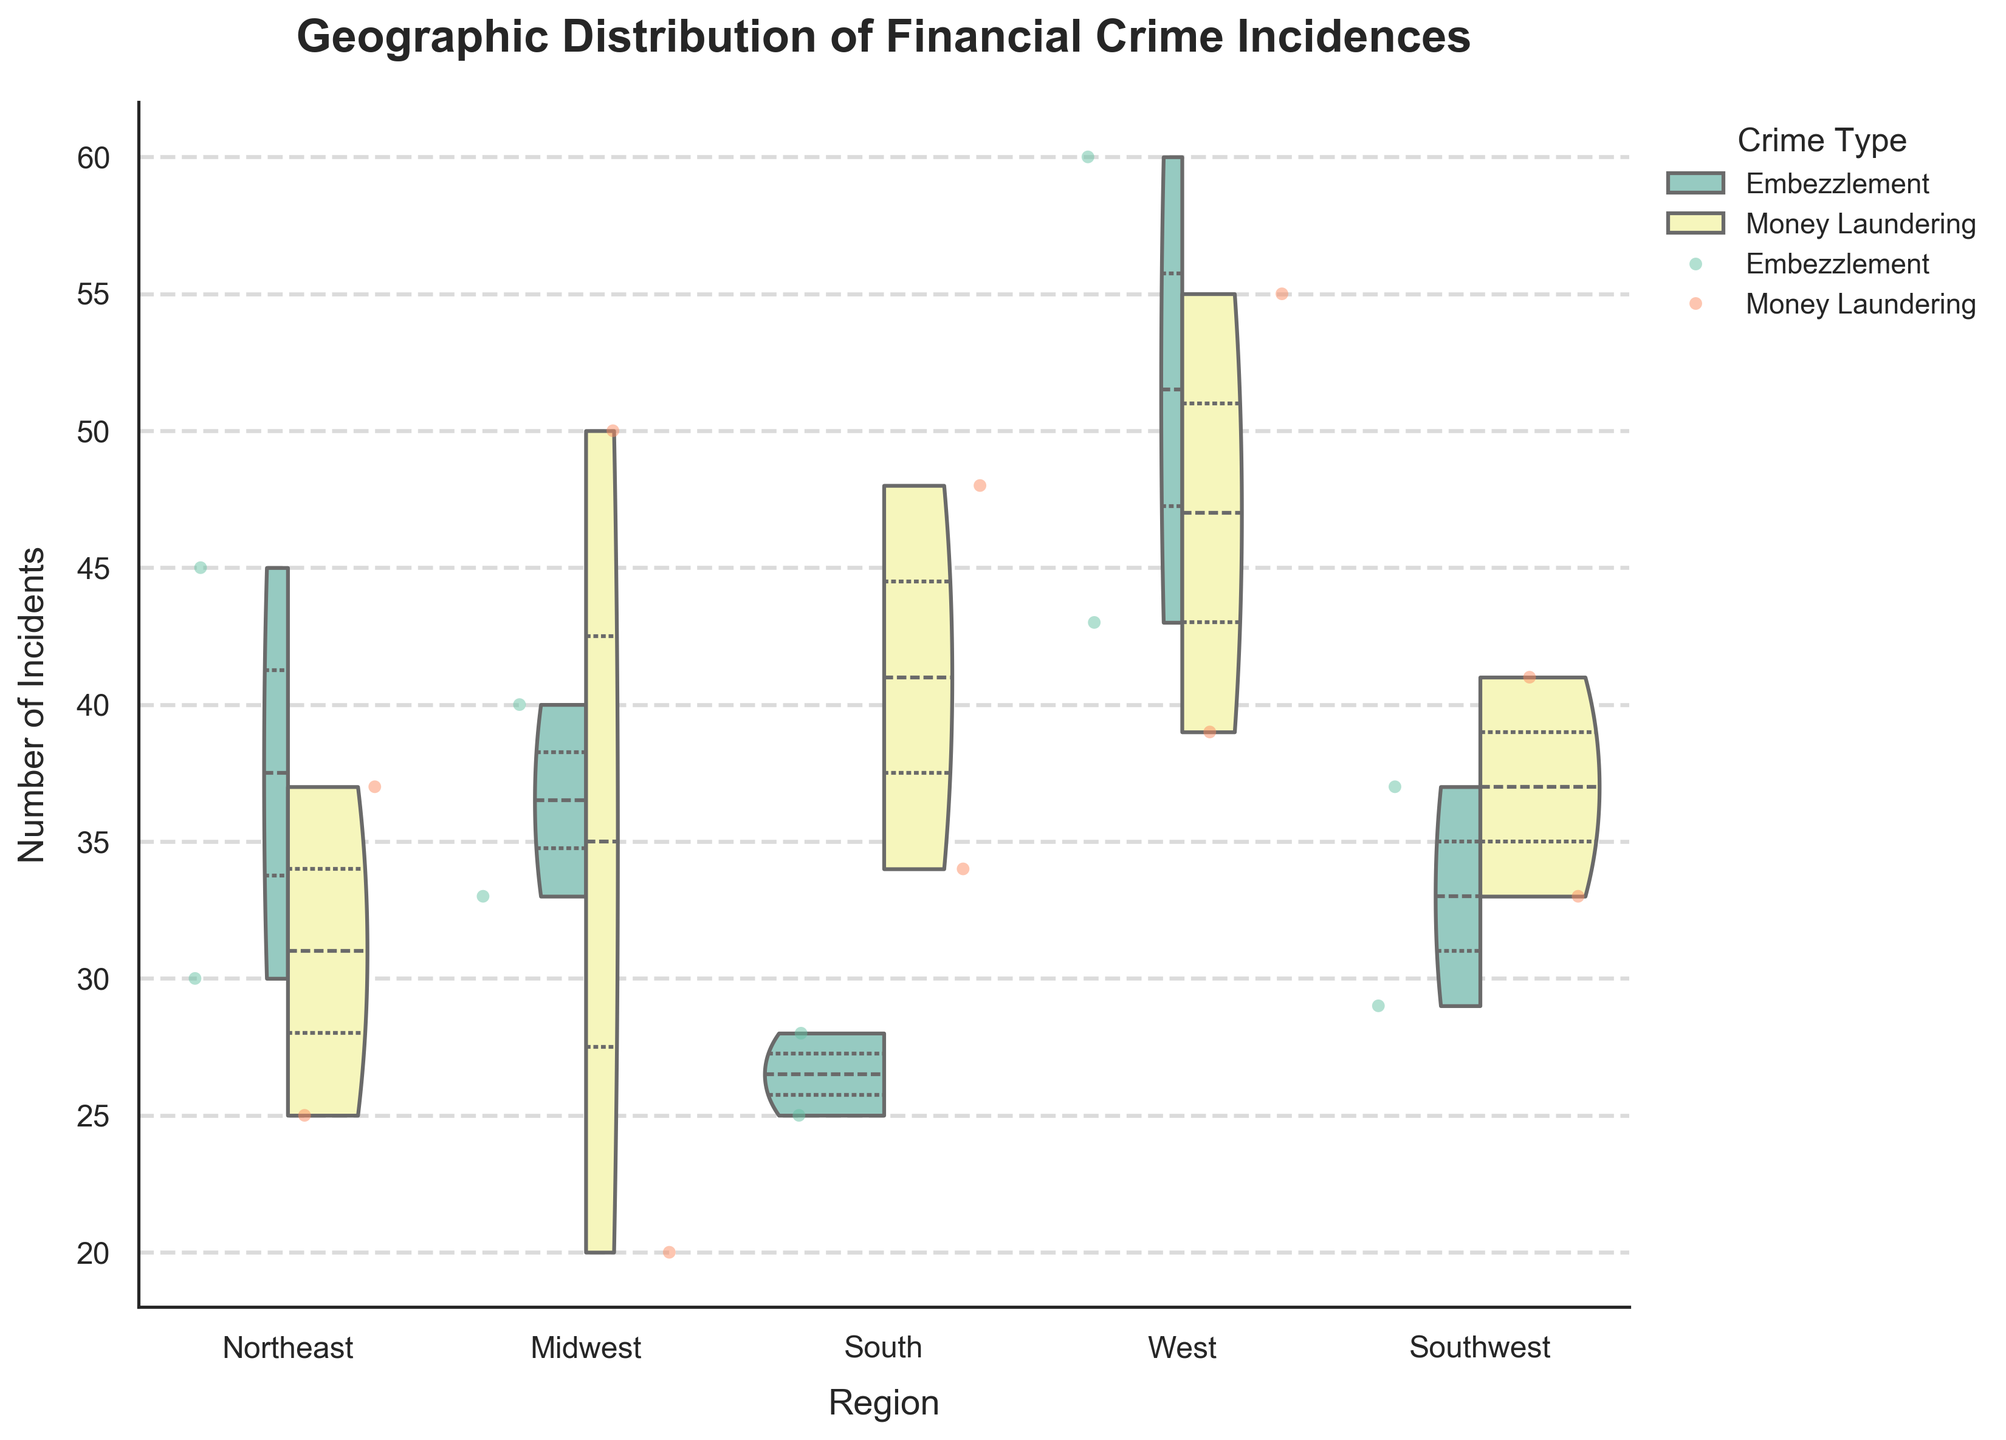what is the title of the figure? The title of the figure is written at the top and reads "Geographic Distribution of Financial Crime Incidences"
Answer: Geographic Distribution of Financial Crime Incidences what is the highest number of incidents for the "Southwest" region? Look for the highest point of the jittered points or the top value of the violin plot on the y-axis for the "Southwest" region.
Answer: 41 what’s the range of embezzlement incidents in the “West” region? Find the height of the violin plot segment specific to embezzlement within the "West" region. The highest point is 60 and the lowest point is 43.
Answer: 17 which region has the highest overall range of incidents? Identify the region with the widest range on the y-axis by comparing the top and bottom points of the violin plots. The "West" region shows the widest range from around 39 to 60 incidents.
Answer: West what can be inferred about the median incidents of money laundering in the “Midwest” region? Look at the location of the median line (darker inner line) inside the violin plot segment for Money Laundering in the "Midwest" region. It is slightly above the midpoint of the entire plot for that region.
Answer: It's around 50 are there more incidents of embezzlement or money laundering in the “Northeast"? Look at the height and density distribution of the jittered points for embezzlement and money laundering in the "Northeast" region. Embezzlement points are higher.
Answer: Embezzlement how does the distribution of crime types in “West” compare to "Southwest"? Observe the violin plots for both "West" and "Southwest" regions. The "West" region has a larger range and higher density of incidents compared to the "Southwest" for both crime types.
Answer: West has a larger range and higher density which city has the most incidents of financial crime in the “South”? Look at the highest points for each city within the "South" region. Miami shows a point at 48 incidents, which is higher than Atlanta.
Answer: Miami between “Embezzlement” and “Money Laundering”, which has the wider range in the “Southwest”? Compare the violin plot segments for "Embezzlement" and "Money Laundering" in the "Southwest" region. Both are relatively close, but "Money Laundering" ranges from around 33 to 41.
Answer: Money Laundering 